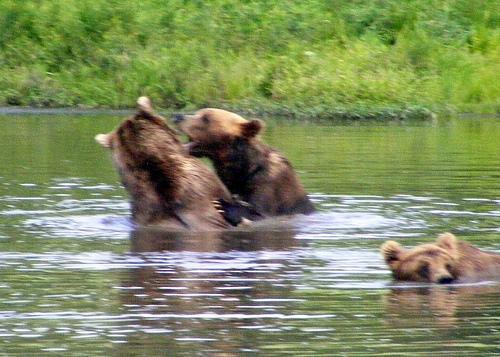How many bears are in the water?
Give a very brief answer. 3. How many bears are standing up?
Give a very brief answer. 2. How many bears are fully submerged in the water?
Give a very brief answer. 1. 